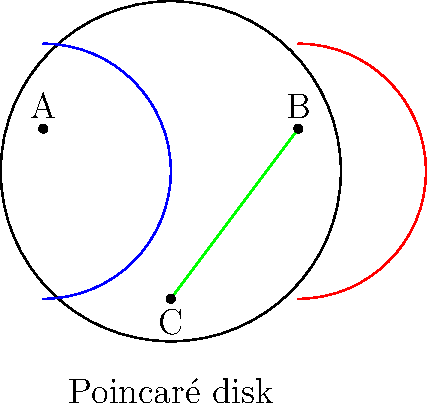In the Poincaré disk model of hyperbolic geometry shown above, three lines are drawn: a blue arc, a red arc, and a green straight line. Which of these lines, if any, are parallel to each other according to the non-Euclidean geometry of the Poincaré disk? Explain your reasoning based on the properties of parallel lines in this model. To answer this question, we need to understand the properties of parallel lines in the Poincaré disk model:

1. In the Poincaré disk model, straight lines are represented by either diameters of the disk or arcs of circles that intersect the boundary of the disk at right angles.

2. Two lines are considered parallel if they do not intersect within the disk.

3. The curvature of space in this model is negative and constant, which allows for more than one line to be parallel to a given line through a point not on that line.

Now, let's analyze each line:

1. The blue arc (l1) is a geodesic in this model, as it's an arc of a circle perpendicular to the boundary.
2. The red arc (l2) is also a geodesic for the same reason.
3. The green line (l3) is a diameter of the disk, which is also a geodesic in this model.

Examining their relationships:

- The blue and red arcs do not intersect within the disk. They appear to meet at the boundary, but in hyperbolic geometry, parallel lines can appear to converge asymptotically.
- The green line intersects both the blue and red arcs within the disk.

Therefore, the blue and red arcs are parallel to each other, while the green line is not parallel to either of them.

This demonstrates a key feature of hyperbolic geometry: through a point not on a given line, there can be multiple lines parallel to the given line, which is not possible in Euclidean geometry.
Answer: The blue and red arcs are parallel to each other. 